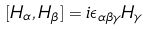<formula> <loc_0><loc_0><loc_500><loc_500>[ H _ { \alpha } , H _ { \beta } ] = i \epsilon _ { \alpha \beta \gamma } H _ { \gamma }</formula> 